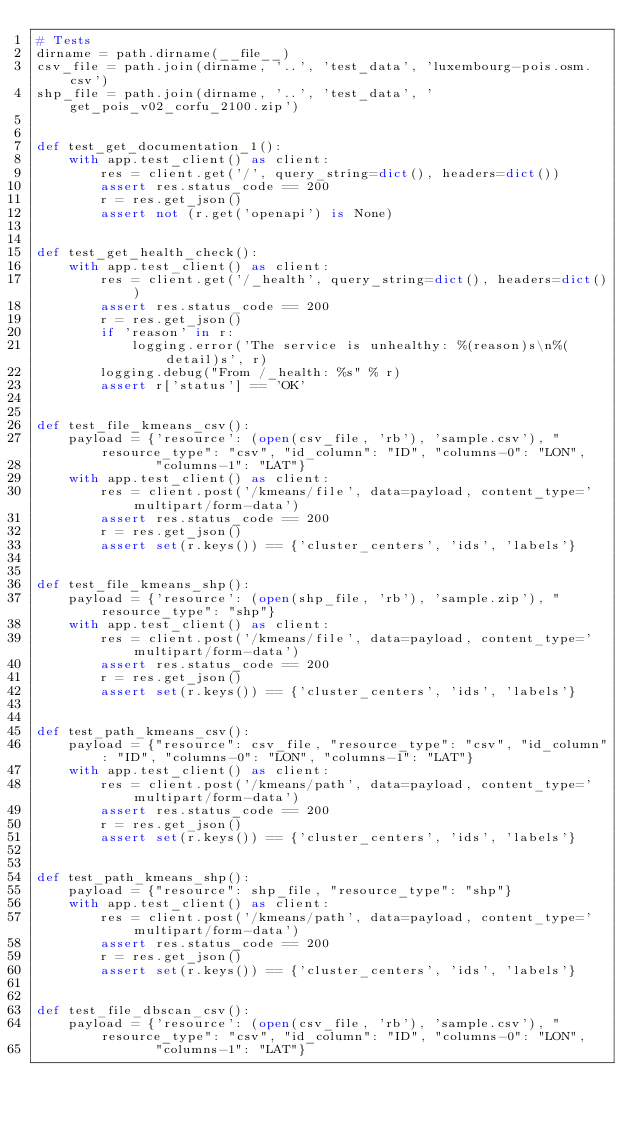<code> <loc_0><loc_0><loc_500><loc_500><_Python_># Tests
dirname = path.dirname(__file__)
csv_file = path.join(dirname, '..', 'test_data', 'luxembourg-pois.osm.csv')
shp_file = path.join(dirname, '..', 'test_data', 'get_pois_v02_corfu_2100.zip')


def test_get_documentation_1():
    with app.test_client() as client:
        res = client.get('/', query_string=dict(), headers=dict())
        assert res.status_code == 200
        r = res.get_json()
        assert not (r.get('openapi') is None)


def test_get_health_check():
    with app.test_client() as client:
        res = client.get('/_health', query_string=dict(), headers=dict())
        assert res.status_code == 200
        r = res.get_json()
        if 'reason' in r:
            logging.error('The service is unhealthy: %(reason)s\n%(detail)s', r)
        logging.debug("From /_health: %s" % r)
        assert r['status'] == 'OK'


def test_file_kmeans_csv():
    payload = {'resource': (open(csv_file, 'rb'), 'sample.csv'), "resource_type": "csv", "id_column": "ID", "columns-0": "LON",
               "columns-1": "LAT"}
    with app.test_client() as client:
        res = client.post('/kmeans/file', data=payload, content_type='multipart/form-data')
        assert res.status_code == 200
        r = res.get_json()
        assert set(r.keys()) == {'cluster_centers', 'ids', 'labels'}


def test_file_kmeans_shp():
    payload = {'resource': (open(shp_file, 'rb'), 'sample.zip'), "resource_type": "shp"}
    with app.test_client() as client:
        res = client.post('/kmeans/file', data=payload, content_type='multipart/form-data')
        assert res.status_code == 200
        r = res.get_json()
        assert set(r.keys()) == {'cluster_centers', 'ids', 'labels'}


def test_path_kmeans_csv():
    payload = {"resource": csv_file, "resource_type": "csv", "id_column": "ID", "columns-0": "LON", "columns-1": "LAT"}
    with app.test_client() as client:
        res = client.post('/kmeans/path', data=payload, content_type='multipart/form-data')
        assert res.status_code == 200
        r = res.get_json()
        assert set(r.keys()) == {'cluster_centers', 'ids', 'labels'}


def test_path_kmeans_shp():
    payload = {"resource": shp_file, "resource_type": "shp"}
    with app.test_client() as client:
        res = client.post('/kmeans/path', data=payload, content_type='multipart/form-data')
        assert res.status_code == 200
        r = res.get_json()
        assert set(r.keys()) == {'cluster_centers', 'ids', 'labels'}


def test_file_dbscan_csv():
    payload = {'resource': (open(csv_file, 'rb'), 'sample.csv'), "resource_type": "csv", "id_column": "ID", "columns-0": "LON",
               "columns-1": "LAT"}</code> 